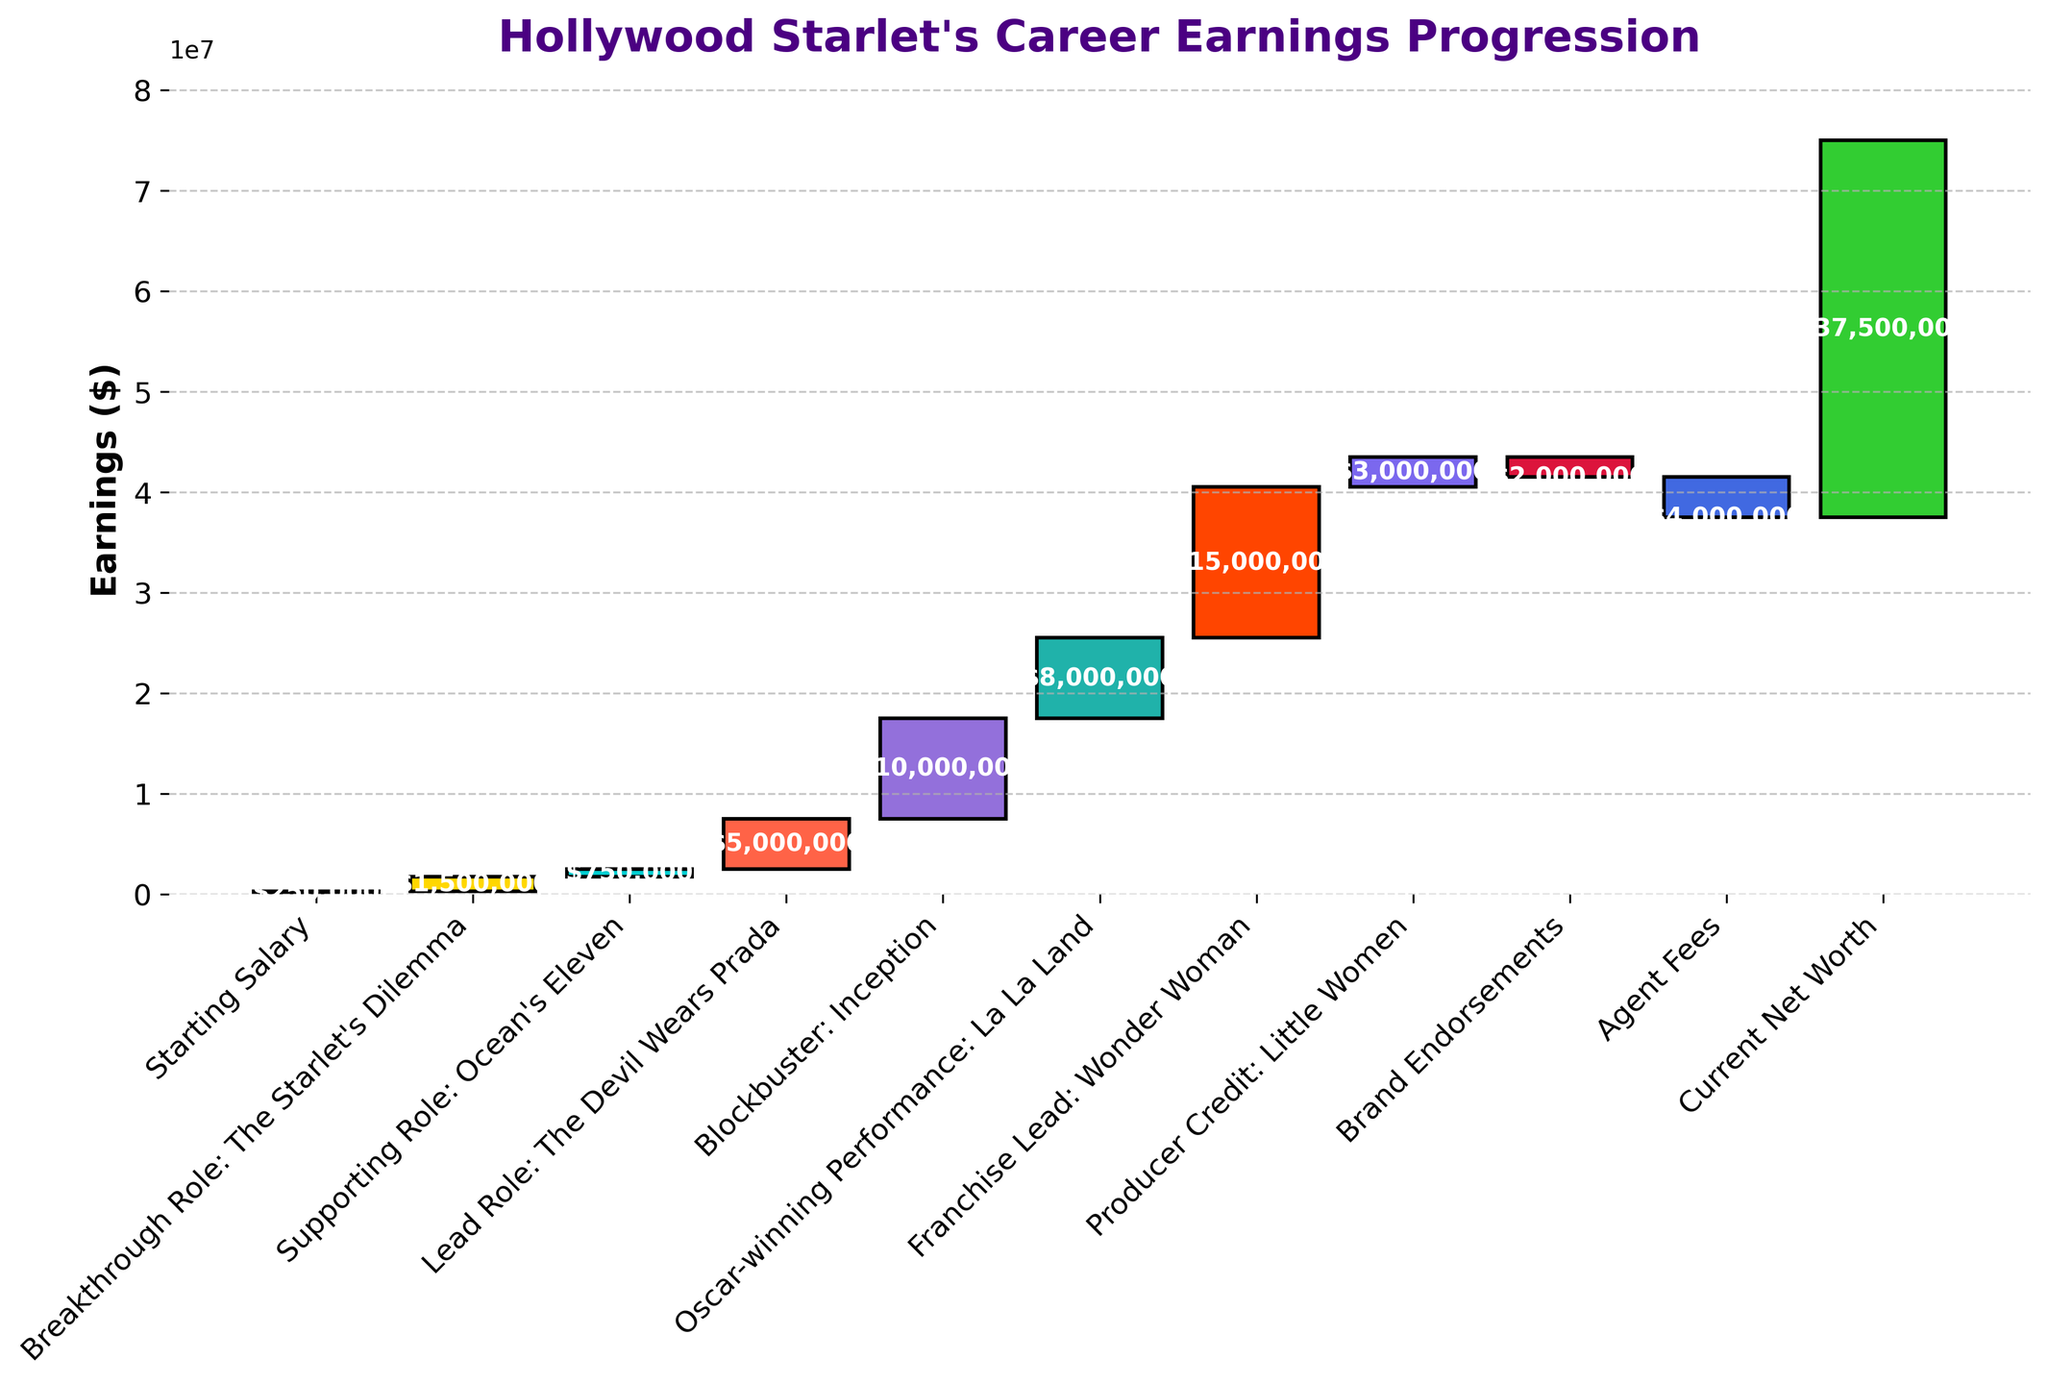How much was the Starting Salary? The first bar in the Waterfall Chart represents the Starting Salary, which is labeled with the value $250,000.
Answer: $250,000 What is the total increase in earnings from the "Breakthrough Role" to the "Lead Role"? The "Breakthrough Role" added $1,500,000 and the "Supporting Role" added $750,000, followed by the "Lead Role" which added $5,000,000. The total sum of these increases is $1,500,000 + $750,000 + $5,000,000 = $7,250,000.
Answer: $7,250,000 Which role contributed the highest earnings increase? The "Franchise Lead: Wonder Woman" role added $15,000,000 to the earnings, which is the highest increase shown on the chart.
Answer: Wonder Woman How did Brand Endorsements and Agent Fees impact the earnings? The Brand Endorsements decreased earnings by $2,000,000 and Agent Fees decreased them further by $4,000,000. Together, these two categories reduced earnings by $6,000,000.
Answer: Decreased by $6,000,000 What is the cumulative earnings before the Agent Fees are deducted? The cumulative earnings before Agent Fees is the earnings sum up to and including the Producer Credit: Little Women. The calculation is: $250,000 + $1,500,000 + $750,000 + $5,000,000 + $10,000,000 + $8,000,000 + $15,000,000 + $3,000,000 = $43,500,000.
Answer: $43,500,000 